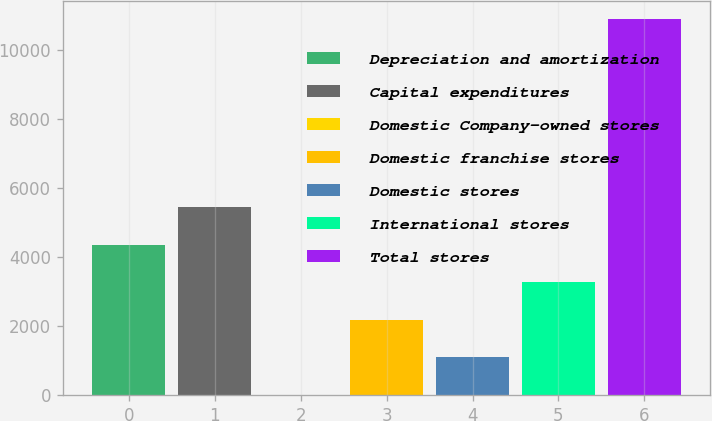Convert chart to OTSL. <chart><loc_0><loc_0><loc_500><loc_500><bar_chart><fcel>Depreciation and amortization<fcel>Capital expenditures<fcel>Domestic Company-owned stores<fcel>Domestic franchise stores<fcel>Domestic stores<fcel>International stores<fcel>Total stores<nl><fcel>4356.74<fcel>5444.95<fcel>3.9<fcel>2180.32<fcel>1092.11<fcel>3268.53<fcel>10886<nl></chart> 